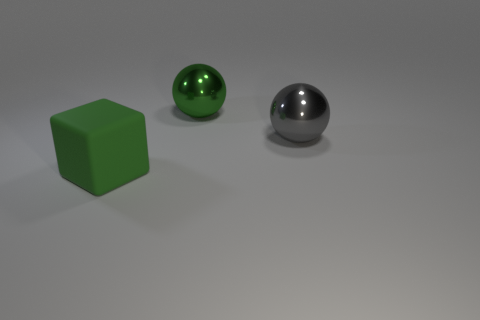Add 1 large red rubber things. How many objects exist? 4 Add 2 green objects. How many green objects exist? 4 Subtract 0 purple cylinders. How many objects are left? 3 Subtract all balls. How many objects are left? 1 Subtract all big matte cylinders. Subtract all gray shiny spheres. How many objects are left? 2 Add 1 big green matte things. How many big green matte things are left? 2 